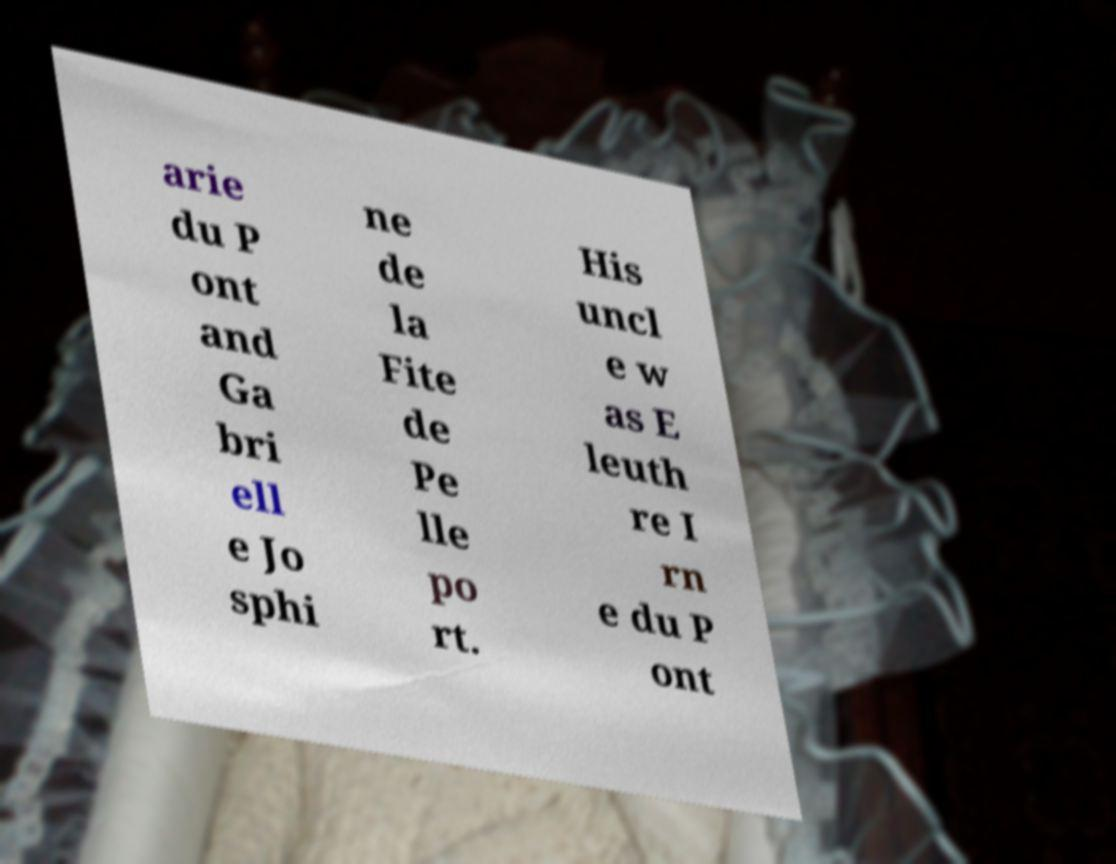What messages or text are displayed in this image? I need them in a readable, typed format. arie du P ont and Ga bri ell e Jo sphi ne de la Fite de Pe lle po rt. His uncl e w as E leuth re I rn e du P ont 